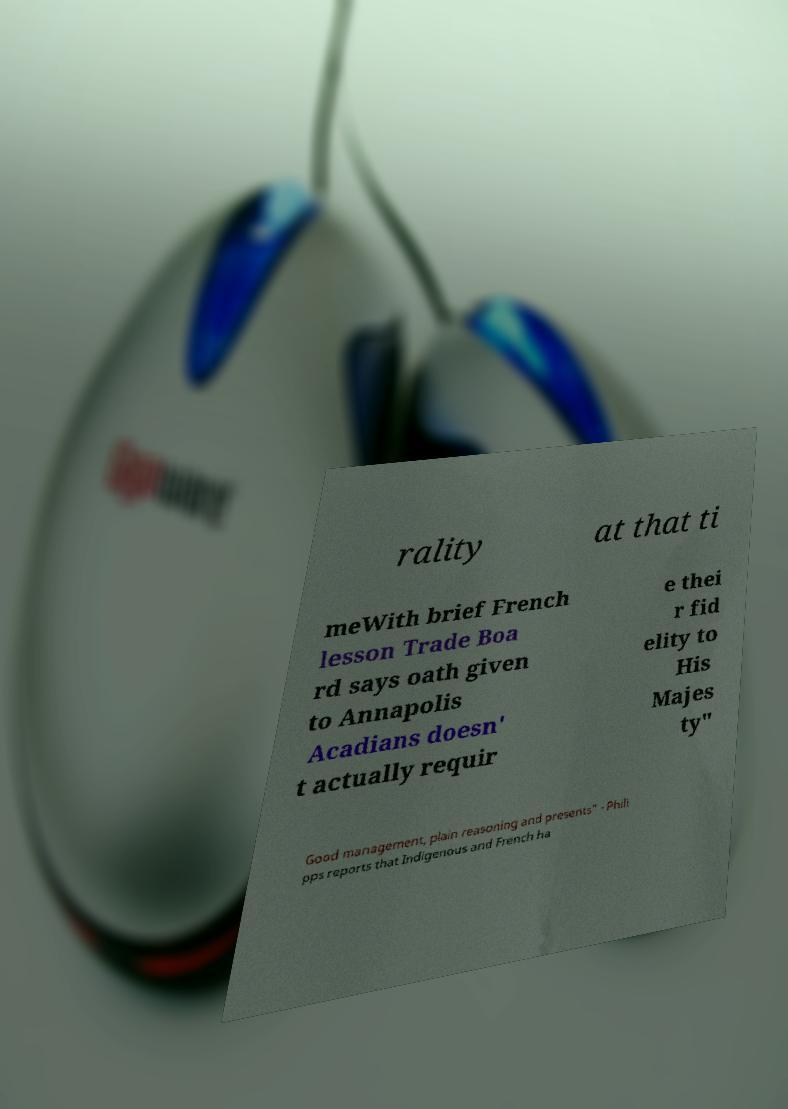Could you assist in decoding the text presented in this image and type it out clearly? rality at that ti meWith brief French lesson Trade Boa rd says oath given to Annapolis Acadians doesn' t actually requir e thei r fid elity to His Majes ty" Good management, plain reasoning and presents" - Phili pps reports that Indigenous and French ha 